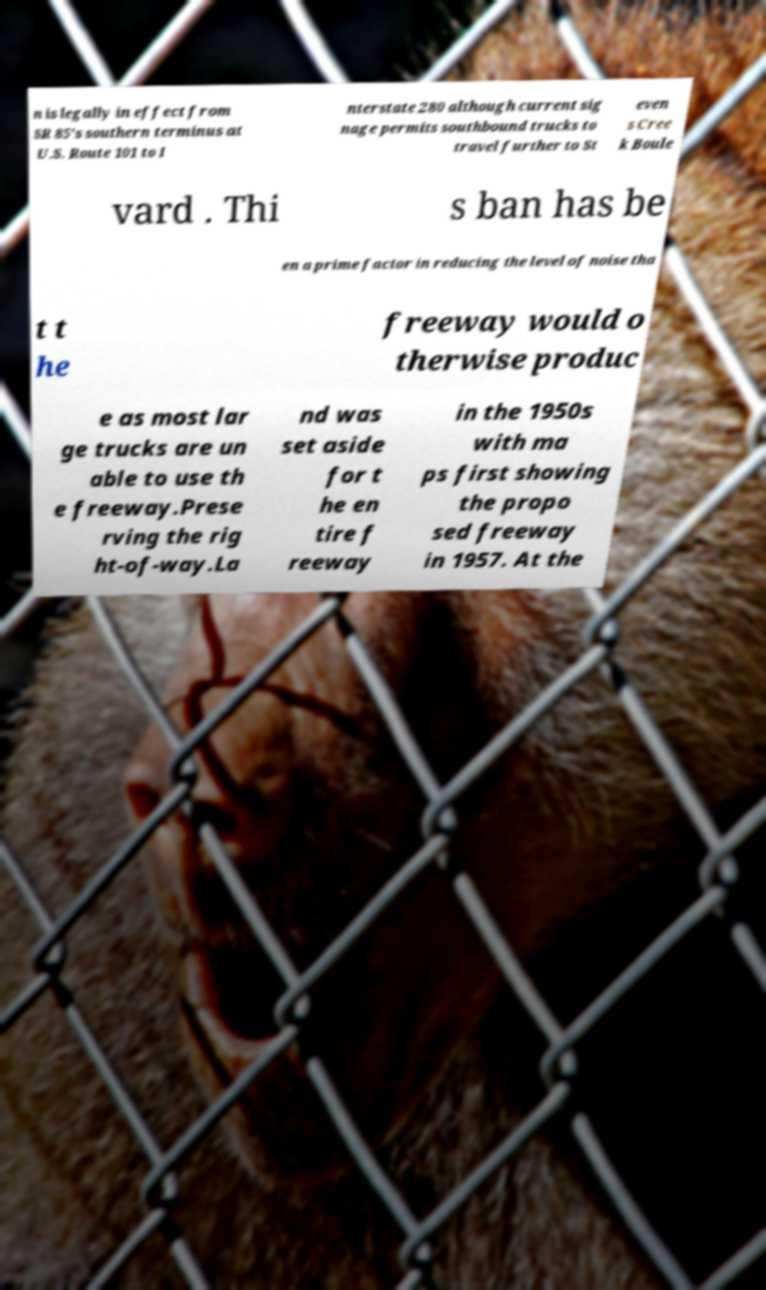Could you extract and type out the text from this image? n is legally in effect from SR 85's southern terminus at U.S. Route 101 to I nterstate 280 although current sig nage permits southbound trucks to travel further to St even s Cree k Boule vard . Thi s ban has be en a prime factor in reducing the level of noise tha t t he freeway would o therwise produc e as most lar ge trucks are un able to use th e freeway.Prese rving the rig ht-of-way.La nd was set aside for t he en tire f reeway in the 1950s with ma ps first showing the propo sed freeway in 1957. At the 